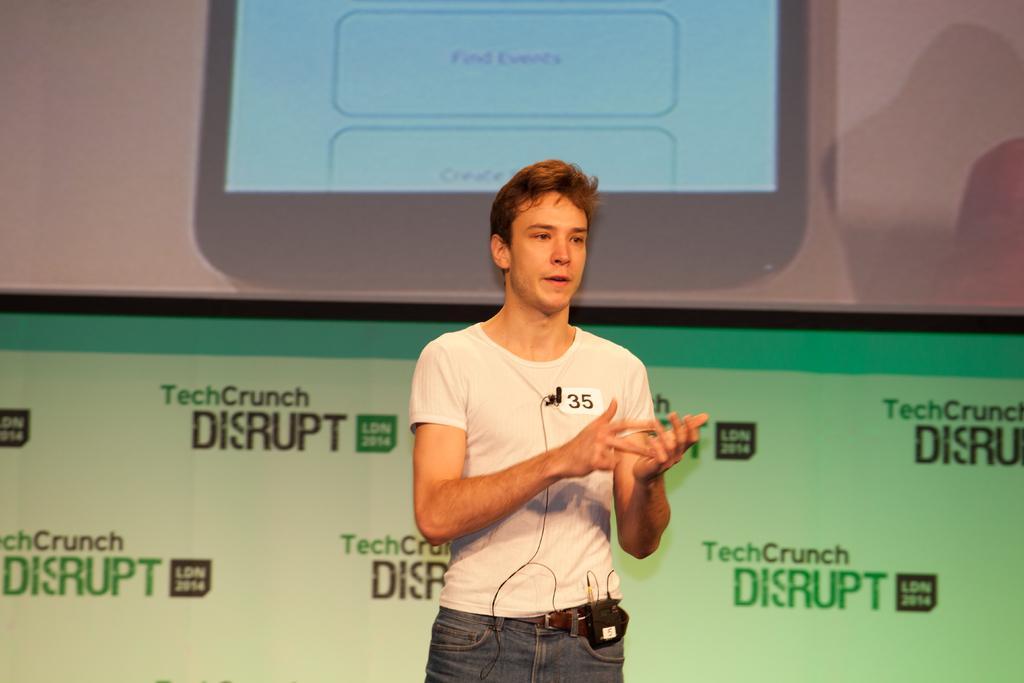Describe this image in one or two sentences. In the center of the image a man is standing. In the background of the image we can see a screen and board are present. 